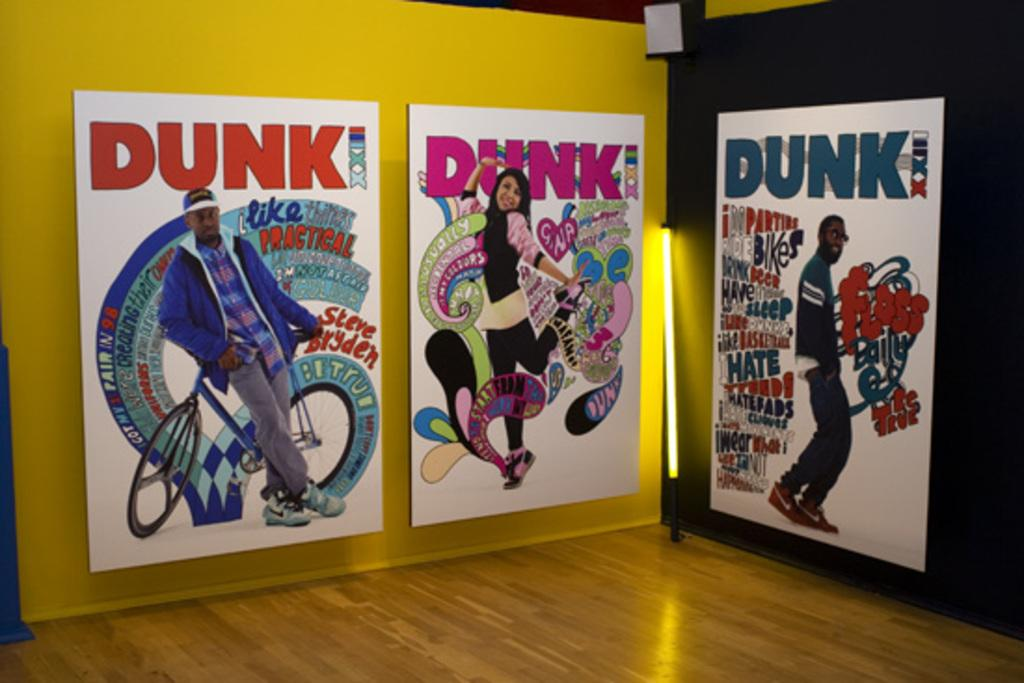<image>
Share a concise interpretation of the image provided. A group of three books all titled Dunk. 